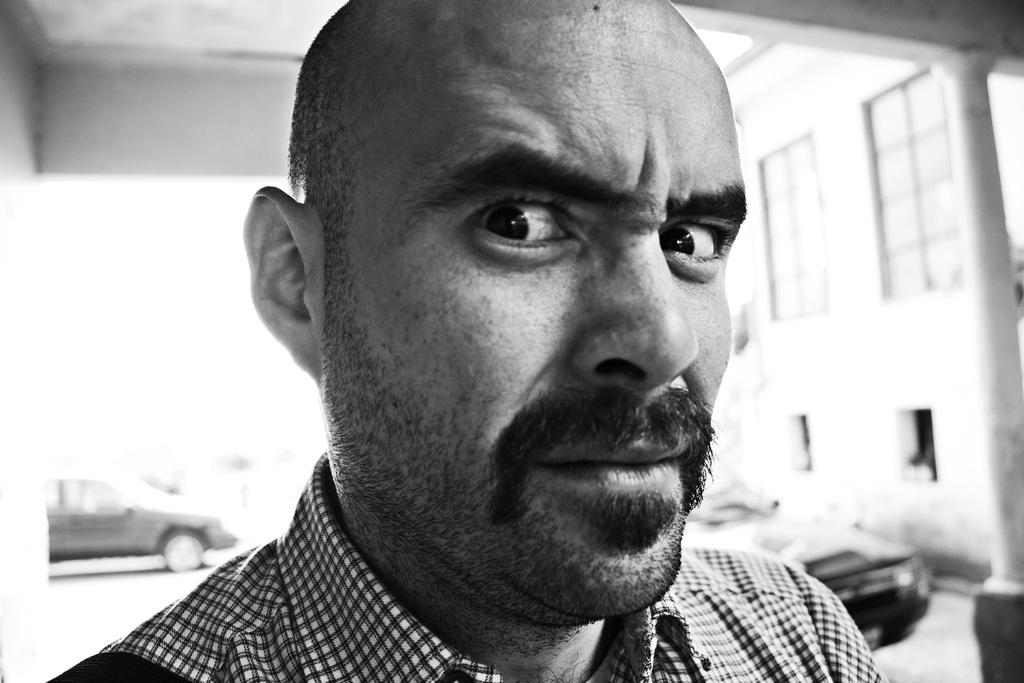What is the main subject of the image? The main subject of the image is a man standing. What structure can be seen in the background of the image? There is a building in the image. What type of vehicles are present in the image? There are at least two cars in the image. What type of cracker can be seen on the lamp in the image? There is no cracker or lamp present in the image. How many bees can be seen flying around the man in the image? There are no bees visible in the image. 